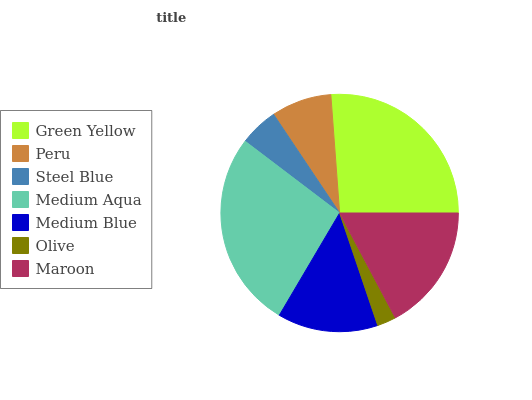Is Olive the minimum?
Answer yes or no. Yes. Is Medium Aqua the maximum?
Answer yes or no. Yes. Is Peru the minimum?
Answer yes or no. No. Is Peru the maximum?
Answer yes or no. No. Is Green Yellow greater than Peru?
Answer yes or no. Yes. Is Peru less than Green Yellow?
Answer yes or no. Yes. Is Peru greater than Green Yellow?
Answer yes or no. No. Is Green Yellow less than Peru?
Answer yes or no. No. Is Medium Blue the high median?
Answer yes or no. Yes. Is Medium Blue the low median?
Answer yes or no. Yes. Is Peru the high median?
Answer yes or no. No. Is Green Yellow the low median?
Answer yes or no. No. 